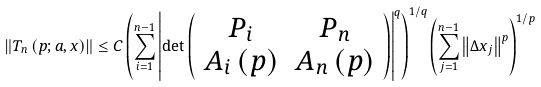<formula> <loc_0><loc_0><loc_500><loc_500>\left \| T _ { n } \left ( p ; a , x \right ) \right \| \leq C \left ( \sum _ { i = 1 } ^ { n - 1 } \left | \det \left ( \begin{array} { c c } P _ { i } & P _ { n } \\ A _ { i } \left ( p \right ) & A _ { n } \left ( p \right ) \end{array} \right ) \right | ^ { q } \right ) ^ { 1 / q } \left ( \sum _ { j = 1 } ^ { n - 1 } \left \| \Delta x _ { j } \right \| ^ { p } \right ) ^ { 1 / p }</formula> 